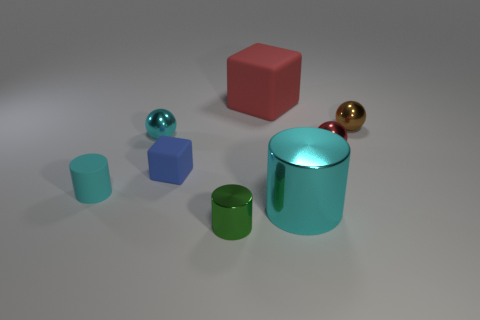Subtract all blue matte things. Subtract all large green metal cylinders. How many objects are left? 7 Add 7 cylinders. How many cylinders are left? 10 Add 5 tiny matte cubes. How many tiny matte cubes exist? 6 Add 1 big brown metallic blocks. How many objects exist? 9 Subtract all blue blocks. How many blocks are left? 1 Subtract all cyan cylinders. How many cylinders are left? 1 Subtract 0 brown blocks. How many objects are left? 8 Subtract all cylinders. How many objects are left? 5 Subtract 1 spheres. How many spheres are left? 2 Subtract all gray spheres. Subtract all yellow cubes. How many spheres are left? 3 